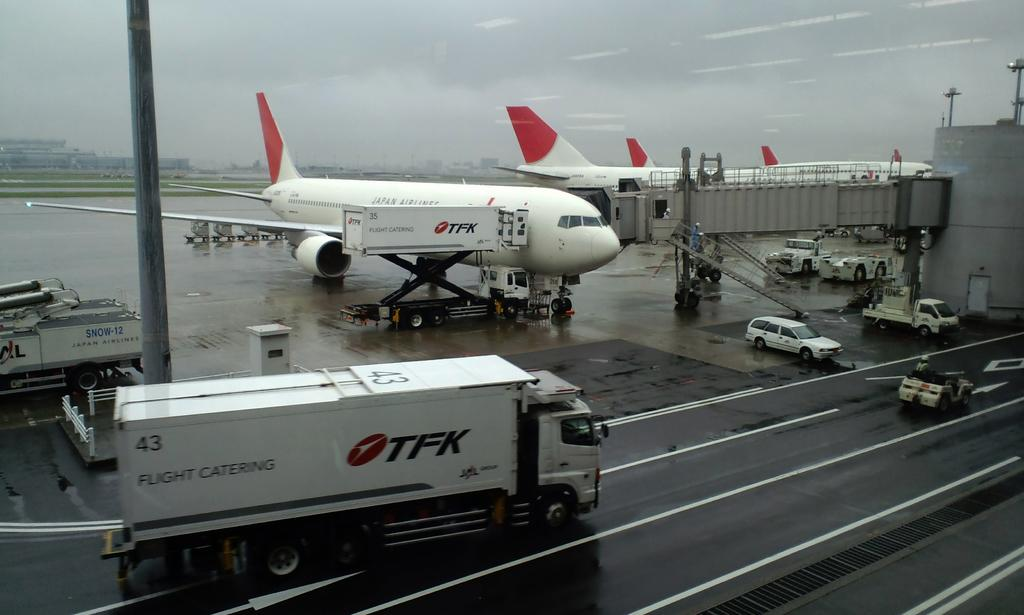<image>
Offer a succinct explanation of the picture presented. A truck with TFK on the side is driving near an airport. 